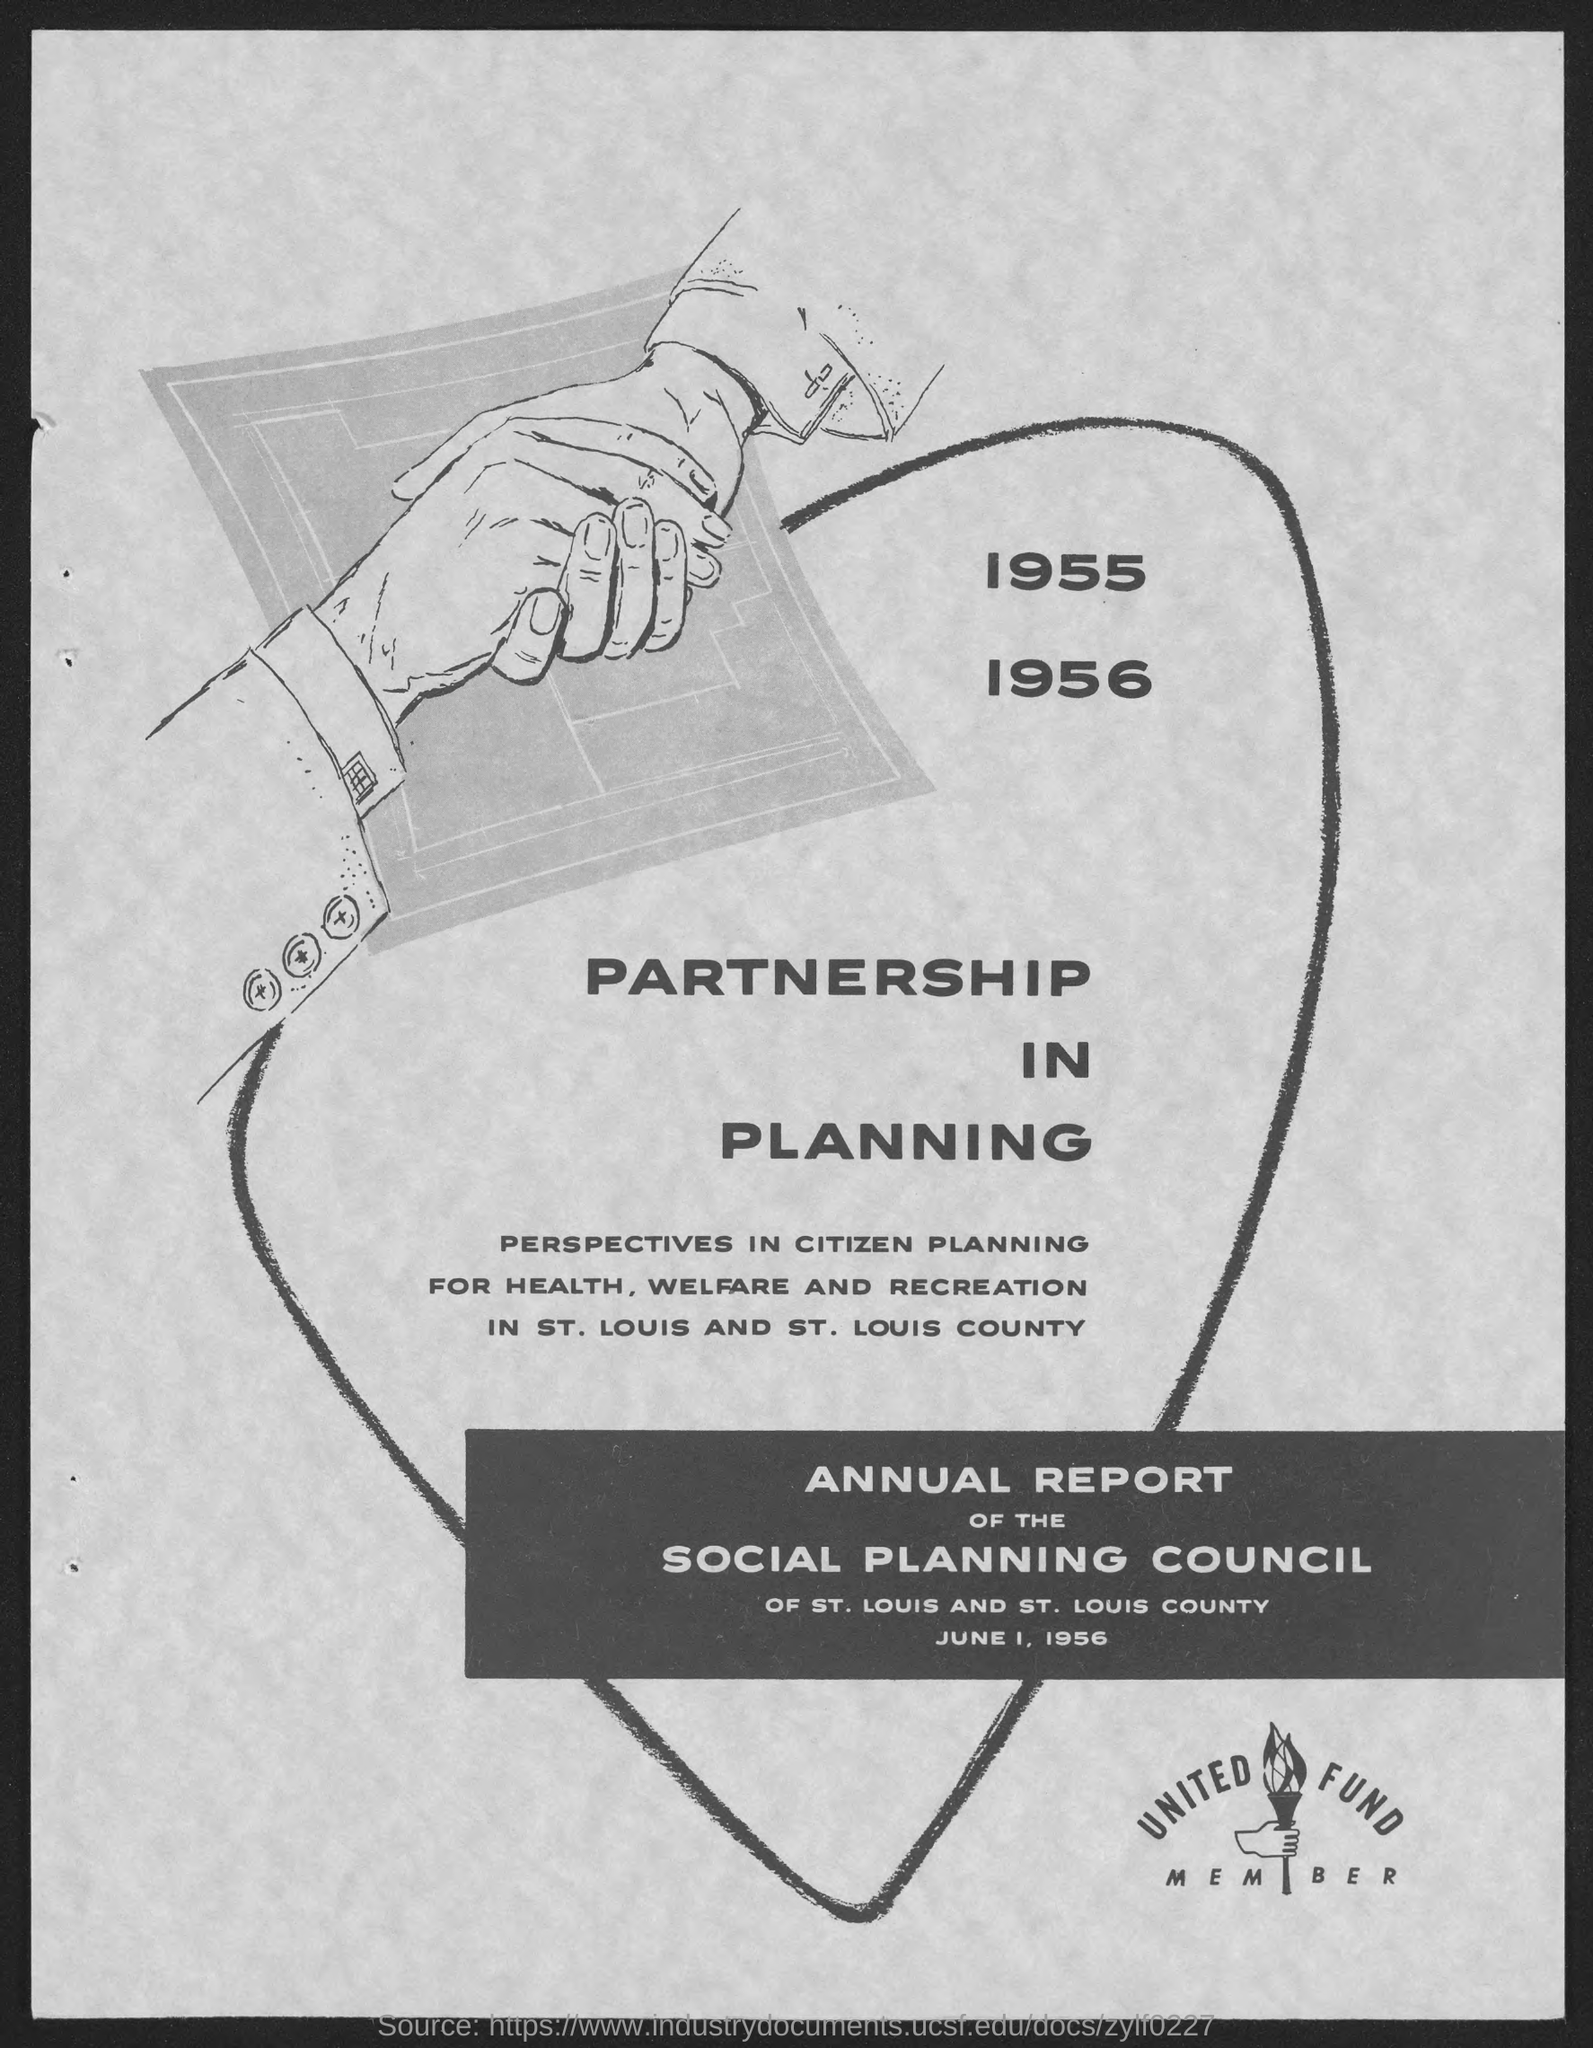What is the heading mentioned in the given page ?
Offer a terse response. Partnership in planning. What is the report consists of as mentioned in the given page ?
Provide a succinct answer. Annual report of the social planning council. What is the date mentioned in the given page ?
Give a very brief answer. June 1, 1956. 